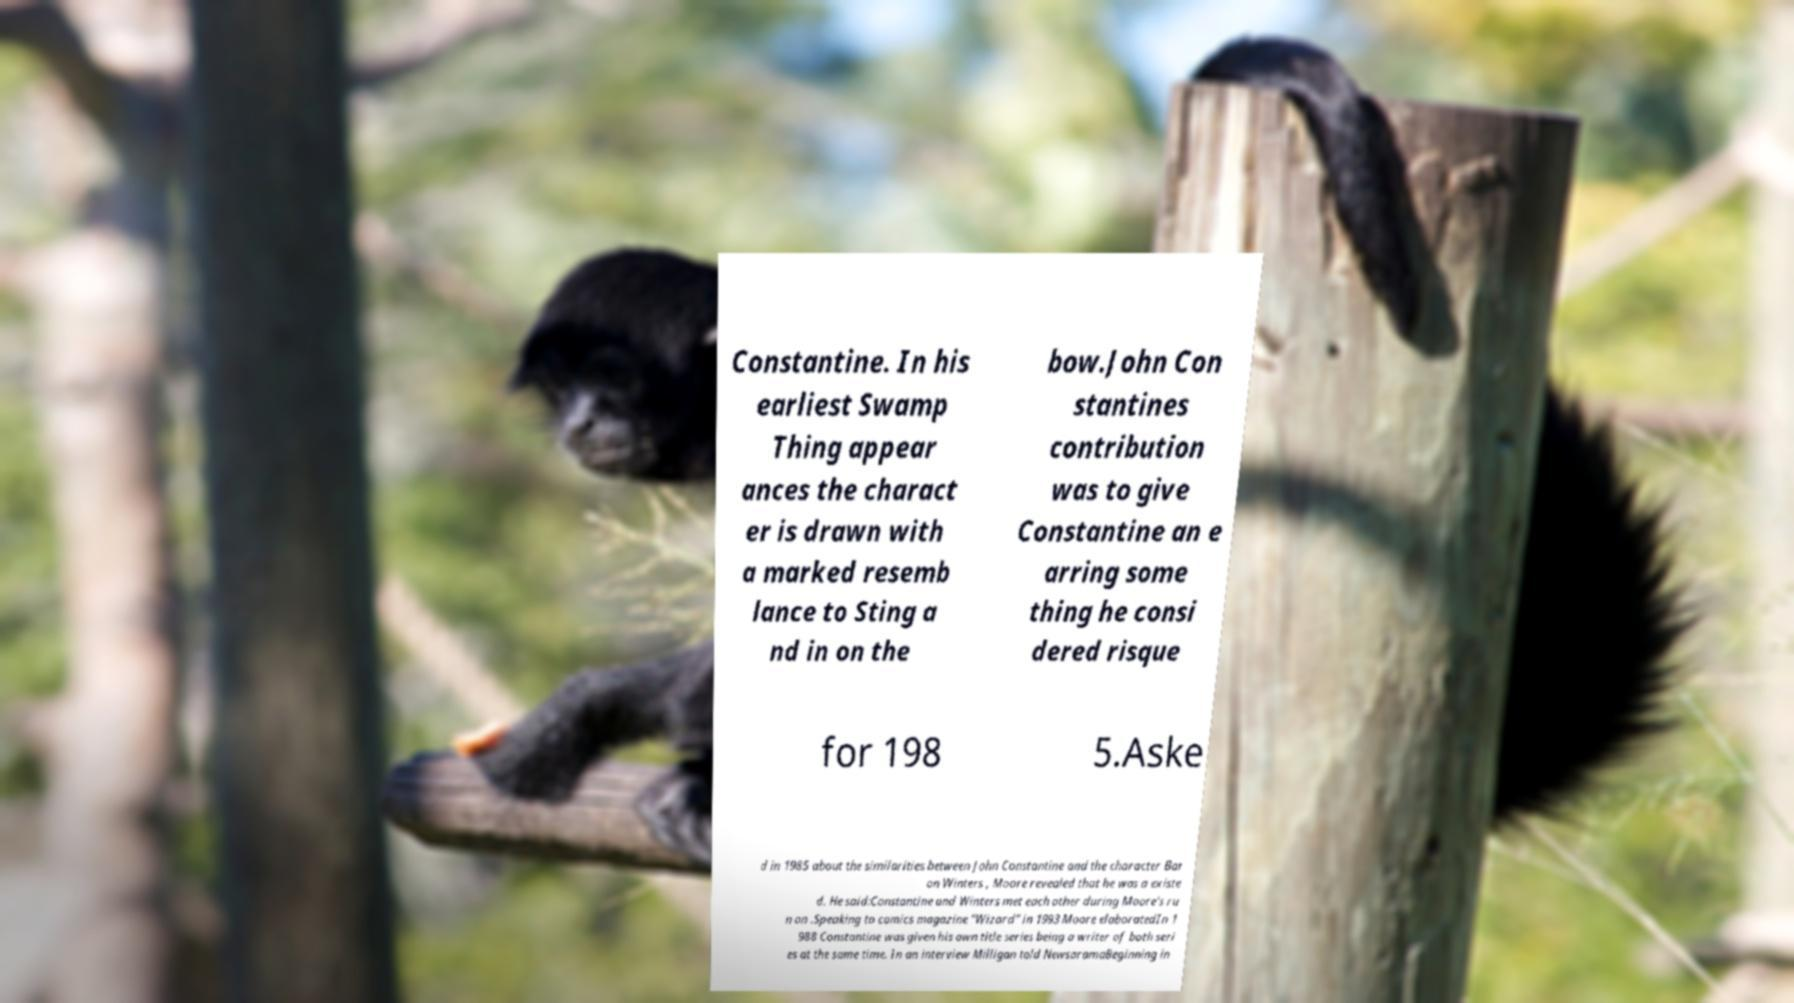Please identify and transcribe the text found in this image. Constantine. In his earliest Swamp Thing appear ances the charact er is drawn with a marked resemb lance to Sting a nd in on the bow.John Con stantines contribution was to give Constantine an e arring some thing he consi dered risque for 198 5.Aske d in 1985 about the similarities between John Constantine and the character Bar on Winters , Moore revealed that he was a existe d. He said:Constantine and Winters met each other during Moore's ru n on .Speaking to comics magazine "Wizard" in 1993 Moore elaboratedIn 1 988 Constantine was given his own title series being a writer of both seri es at the same time. In an interview Milligan told NewsaramaBeginning in 